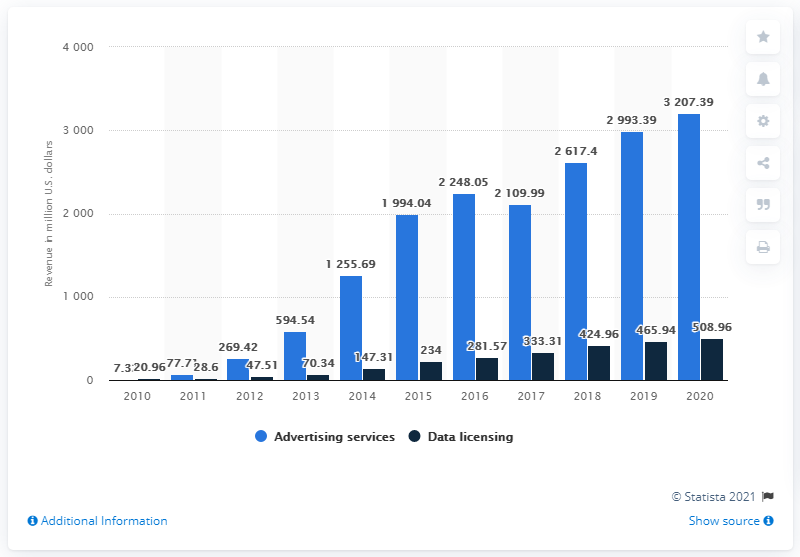Which type of revenue has shown more growth for Twitter over the last decade? Over the last decade, advertising revenue has shown a significant growth for Twitter, escalating from $269.42 million in 2011 to $3.207.39 million in 2020, which indicates a consistent and substantial upward trend. 